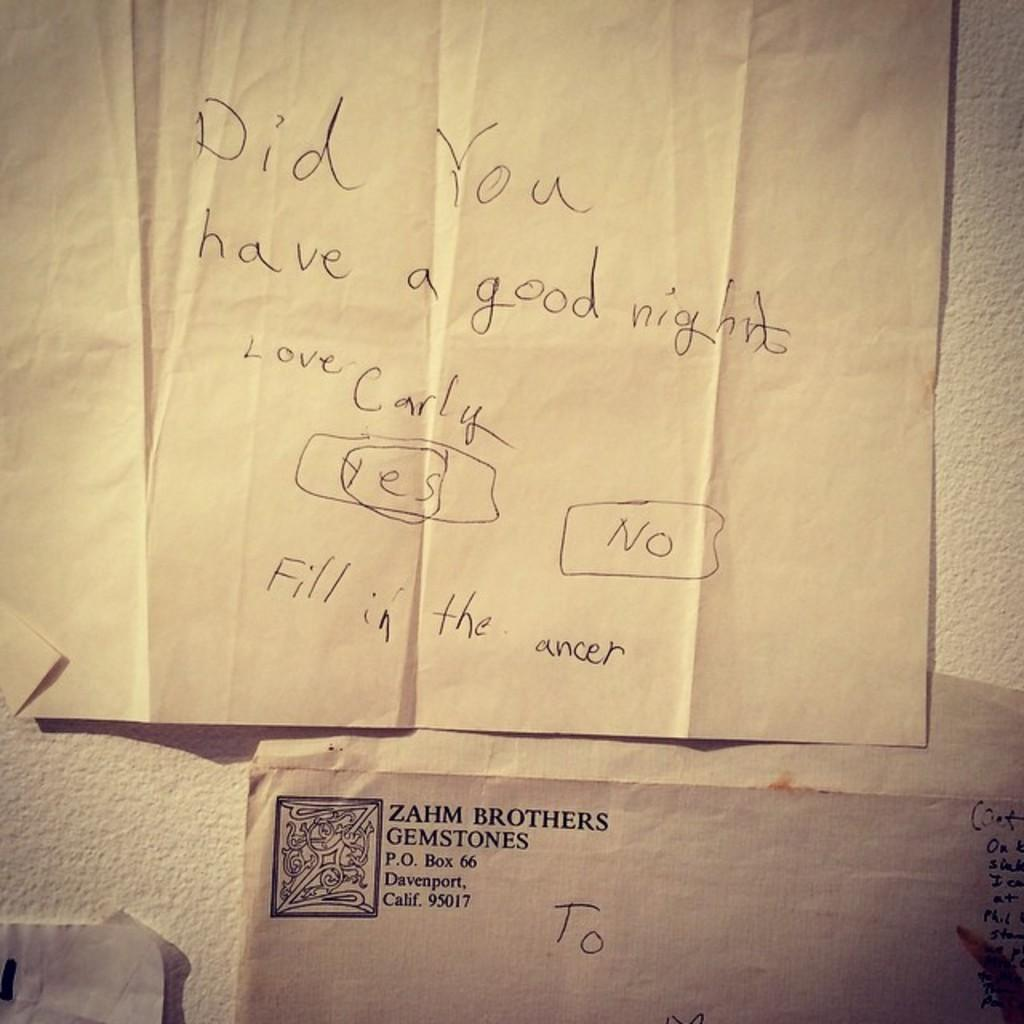Provide a one-sentence caption for the provided image. A letter written on a piece of paper asking if someone had a good night. 